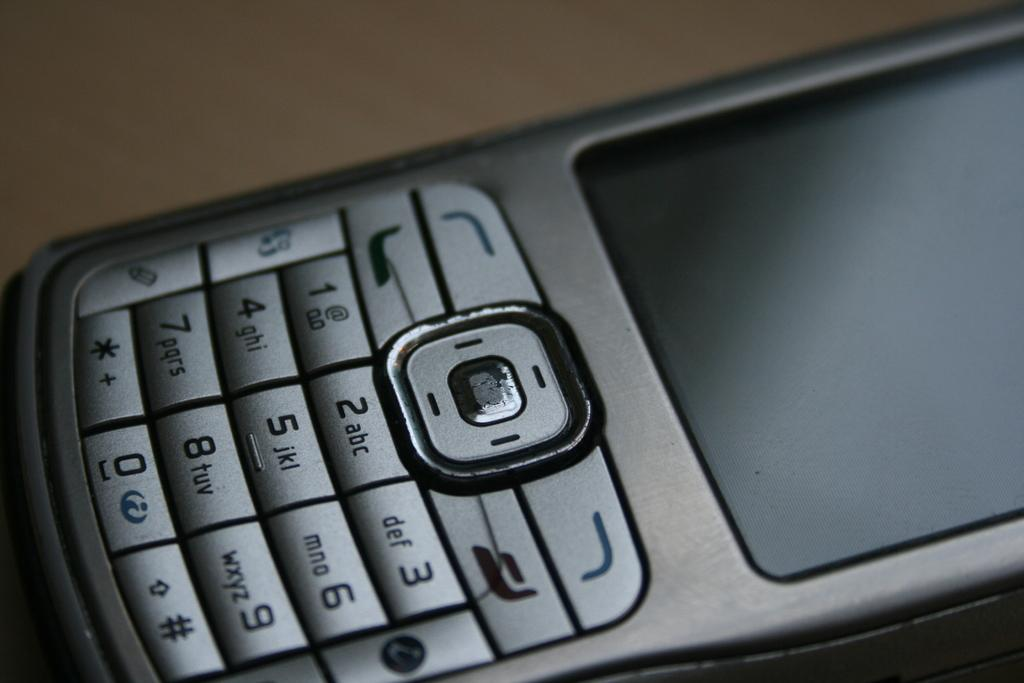<image>
Render a clear and concise summary of the photo. The numbers 1-9 and zero are shown on a cell phone. 